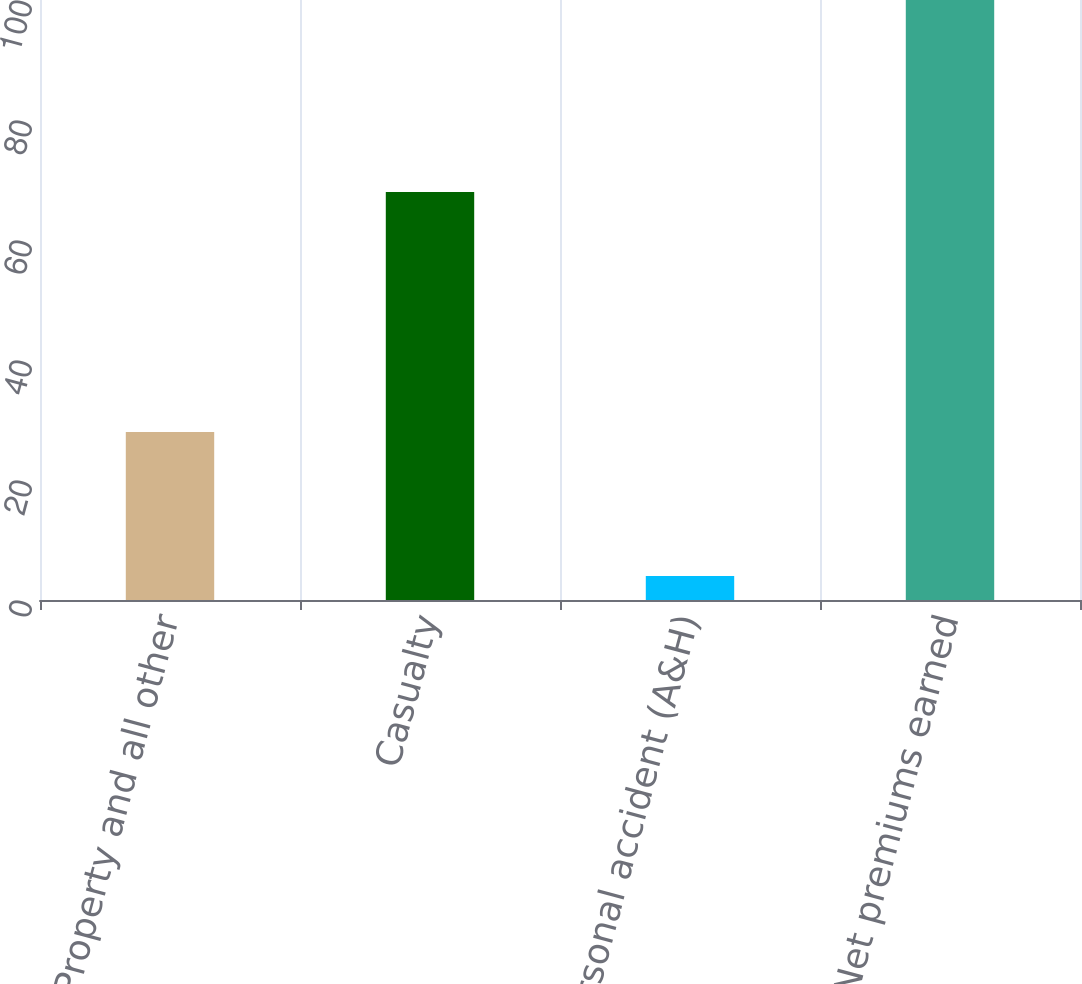Convert chart to OTSL. <chart><loc_0><loc_0><loc_500><loc_500><bar_chart><fcel>Property and all other<fcel>Casualty<fcel>Personal accident (A&H)<fcel>Net premiums earned<nl><fcel>28<fcel>68<fcel>4<fcel>100<nl></chart> 